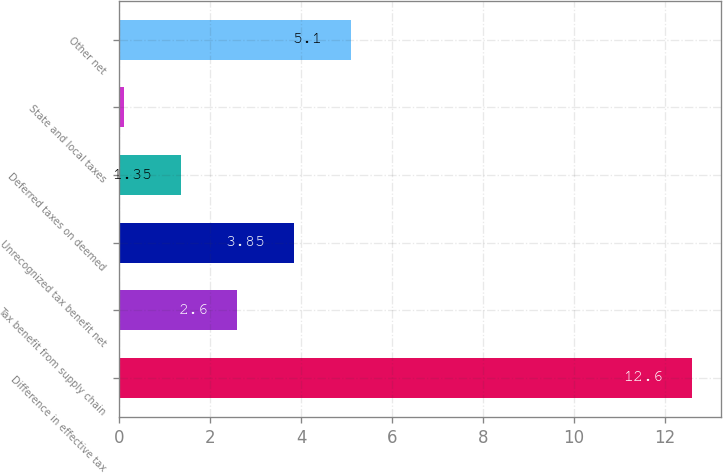Convert chart to OTSL. <chart><loc_0><loc_0><loc_500><loc_500><bar_chart><fcel>Difference in effective tax<fcel>Tax benefit from supply chain<fcel>Unrecognized tax benefit net<fcel>Deferred taxes on deemed<fcel>State and local taxes<fcel>Other net<nl><fcel>12.6<fcel>2.6<fcel>3.85<fcel>1.35<fcel>0.1<fcel>5.1<nl></chart> 